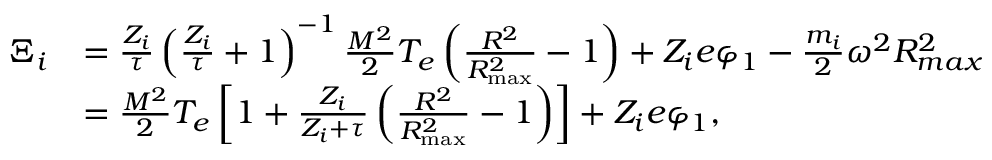Convert formula to latex. <formula><loc_0><loc_0><loc_500><loc_500>\begin{array} { r l } { \Xi _ { i } } & { = \frac { Z _ { i } } { \tau } \left ( \frac { Z _ { i } } { \tau } + 1 \right ) ^ { - 1 } \frac { M ^ { 2 } } { 2 } T _ { e } \left ( \frac { R ^ { 2 } } { R _ { \max } ^ { 2 } } - 1 \right ) + Z _ { i } e \varphi _ { 1 } - \frac { m _ { i } } { 2 } \omega ^ { 2 } R _ { \max } ^ { 2 } } \\ & { = \frac { M ^ { 2 } } { 2 } T _ { e } \left [ 1 + \frac { Z _ { i } } { Z _ { i } + \tau } \left ( \frac { R ^ { 2 } } { R _ { \max } ^ { 2 } } - 1 \right ) \right ] + Z _ { i } e \varphi _ { 1 } , } \end{array}</formula> 